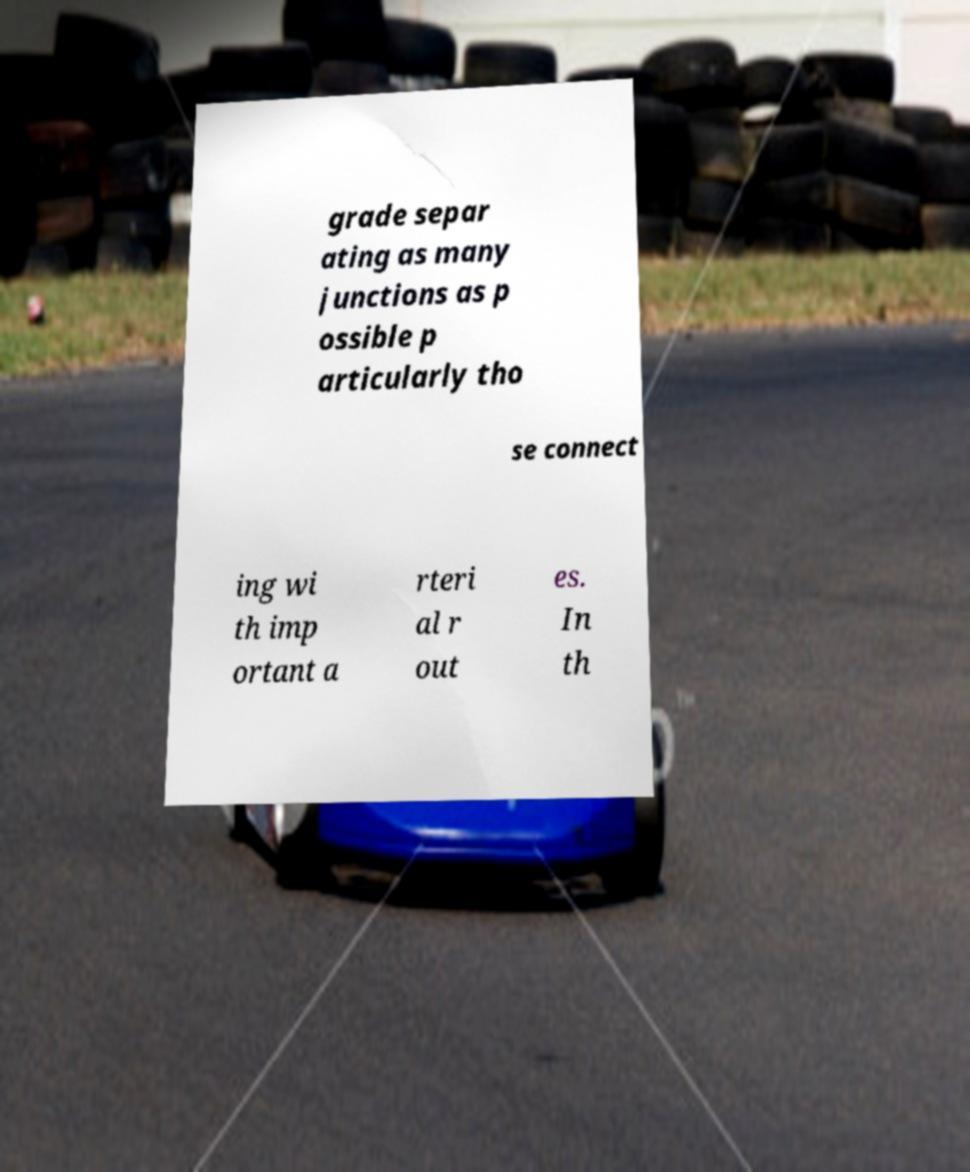For documentation purposes, I need the text within this image transcribed. Could you provide that? grade separ ating as many junctions as p ossible p articularly tho se connect ing wi th imp ortant a rteri al r out es. In th 